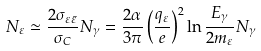<formula> <loc_0><loc_0><loc_500><loc_500>N _ { \varepsilon } \simeq \frac { 2 \sigma _ { \varepsilon \bar { \varepsilon } } } { \sigma _ { C } } N _ { \gamma } = \frac { 2 \alpha } { 3 \pi } \left ( \frac { q _ { \varepsilon } } { e } \right ) ^ { 2 } \ln \frac { E _ { \gamma } } { 2 m _ { \varepsilon } } N _ { \gamma }</formula> 